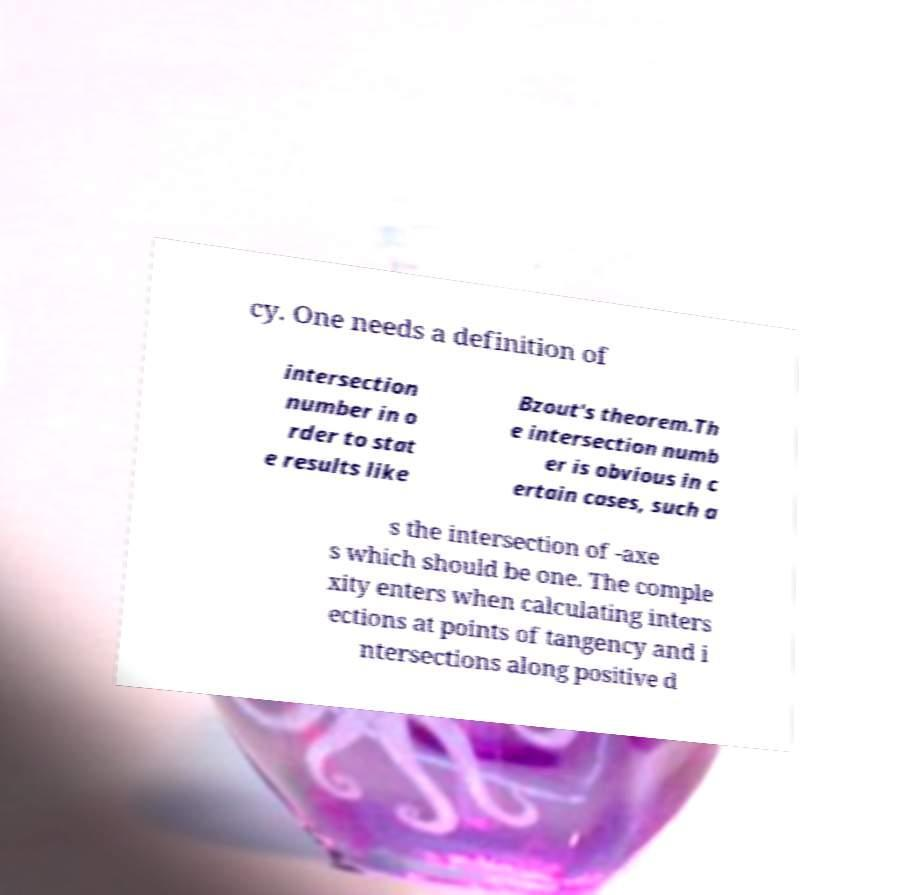Please read and relay the text visible in this image. What does it say? cy. One needs a definition of intersection number in o rder to stat e results like Bzout's theorem.Th e intersection numb er is obvious in c ertain cases, such a s the intersection of -axe s which should be one. The comple xity enters when calculating inters ections at points of tangency and i ntersections along positive d 